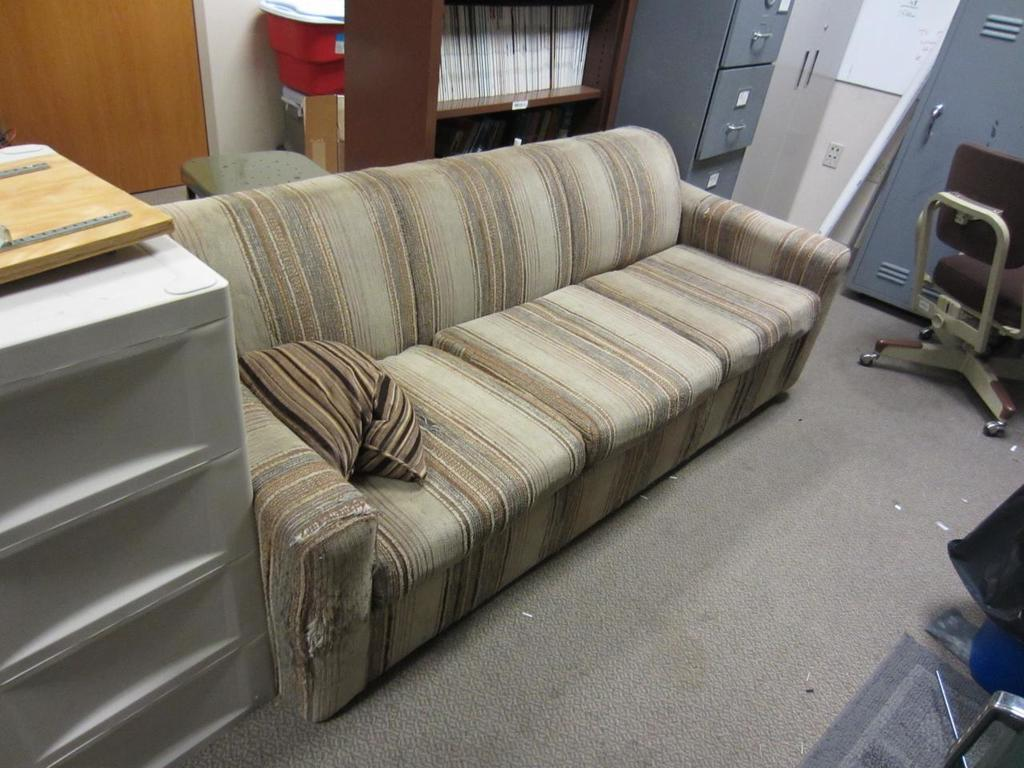What type of furniture is in the image that can be used for seating and sleeping? There is a sofa bed in the image. What type of furniture is in the image that can be used for storing and organizing books? There is a bookshelf in the image. What type of furniture is in the image that can be used for storing items? There are cupboards in the image. What type of furniture is in the image that can be used for seating? There is a chair in the image. What flavor of bulb is hanging above the chair in the image? There is no bulb present in the image, and therefore no flavor can be determined. 